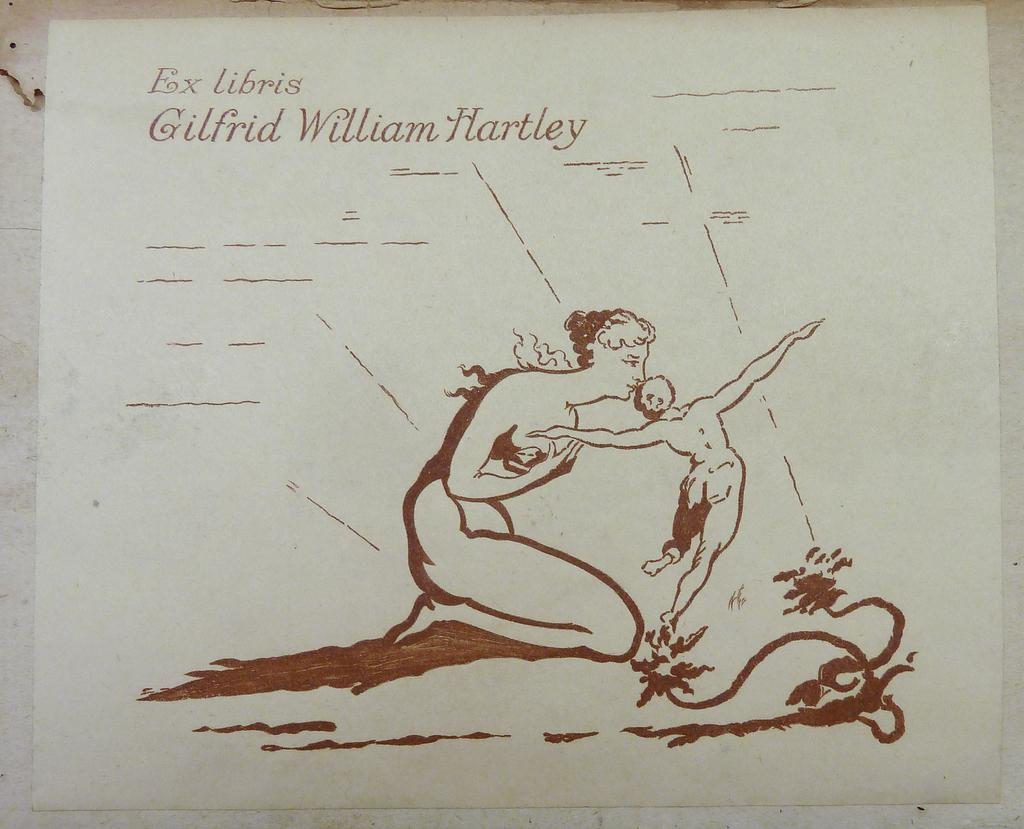What is present on the white paper in the image? There is writing on a white paper in the image. What else can be seen in the image besides the writing on the paper? There is a sketch in the image. What type of rake is being used to create the sketch in the image? There is no rake present in the image; it features writing on a white paper and a sketch. How many trees are visible in the sketch in the image? There is no tree visible in the sketch in the image; it is not mentioned in the provided facts. 